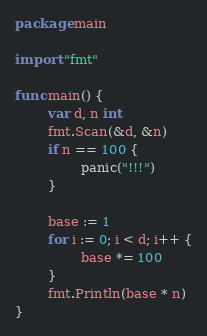Convert code to text. <code><loc_0><loc_0><loc_500><loc_500><_Go_>package main

import "fmt"

func main() {
        var d, n int
        fmt.Scan(&d, &n)
        if n == 100 {
                panic("!!!")
        }

        base := 1
        for i := 0; i < d; i++ {
                base *= 100
        }
        fmt.Println(base * n)
}</code> 